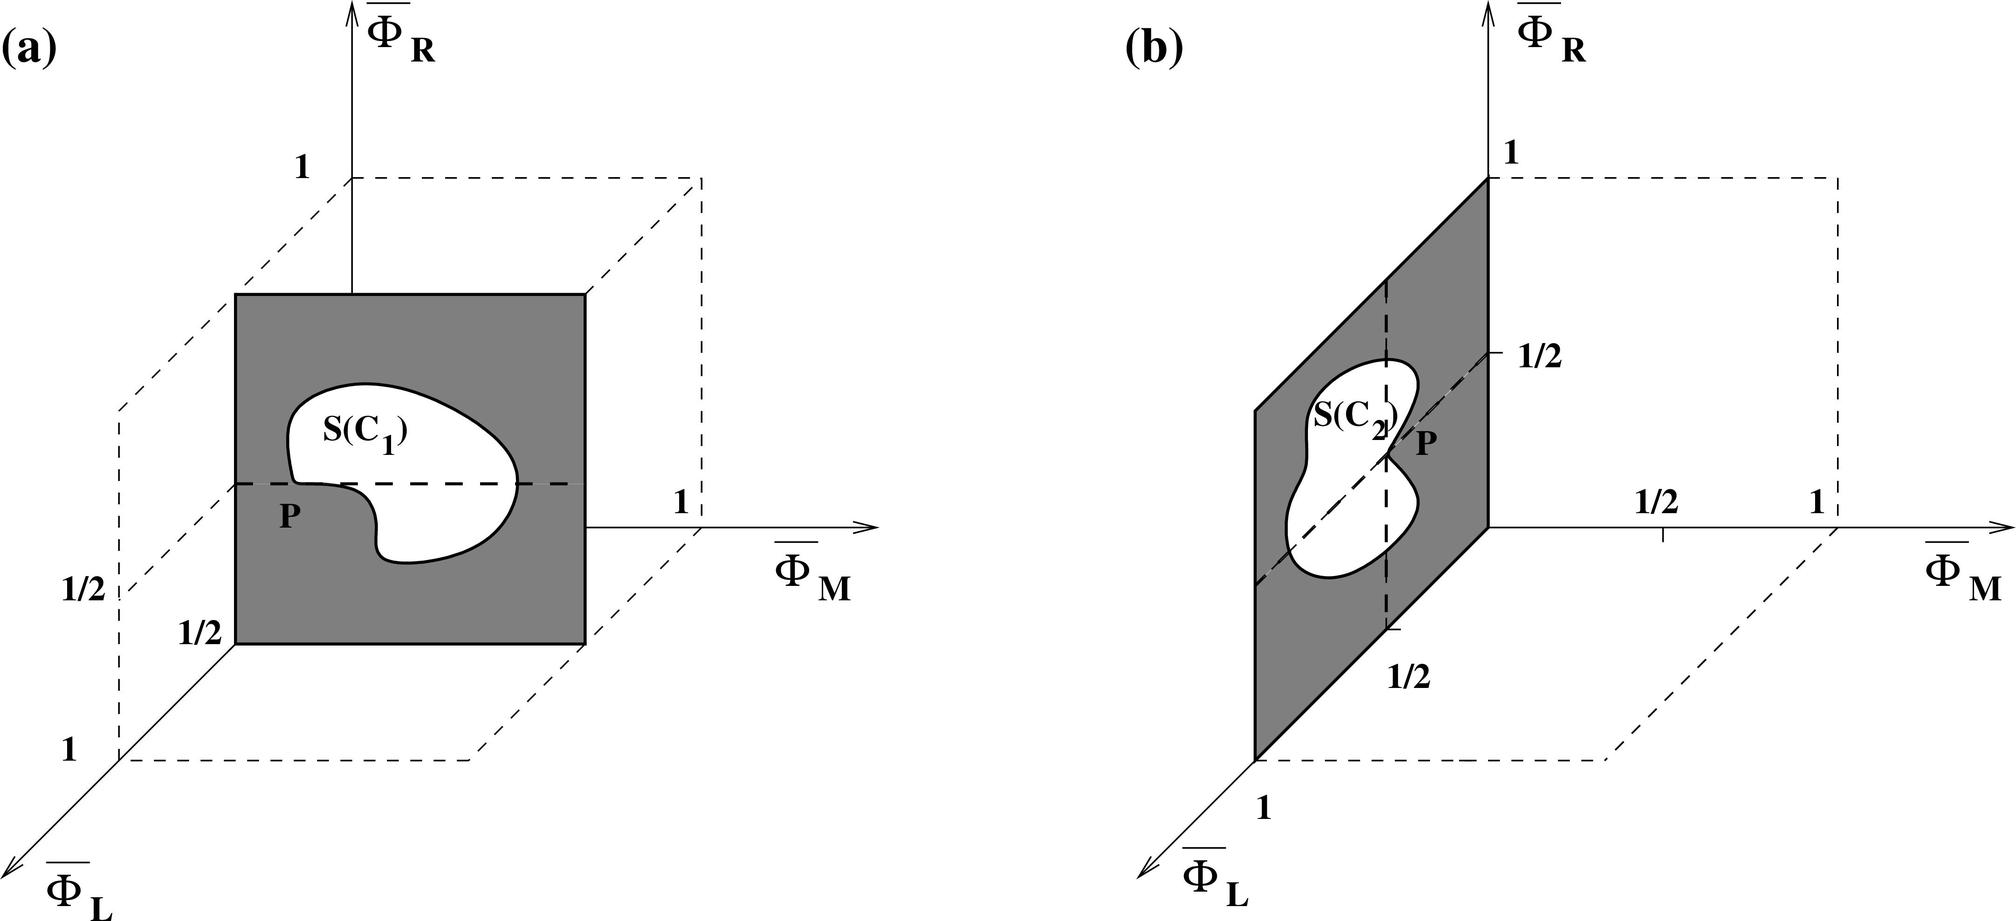Can you explain the significance of the shaded region in both figures? The shaded regions in both diagrams signify the specific area under consideration, labeled as S(C1) and S(C2) respectively. These regions are being analyzed based on their geometric position and area in relation to the overall shapes depicted. The differences in their forms and placements likely imply varied implications on the measurements of Islam and R since their configurations alter how these dimensions are defined and related.  How does the change in shape from S(C1) to S(C2) impact the independence of Islam and R? The change in shape from S(C1) to S(C2), while visually noticeable, does not inherently impact the independence of Islam and R as depicted. Since these dimensions are plotted on separate axes, their independence is maintained regardless of the internal configurations of the regions S(C1) and S(C2). The axes' alignment as perpendicular suggests their measurements stand independently from each other, meaning changes in the shapes affect visual interpretations and possibly practical applications, but not their statistical independence. 